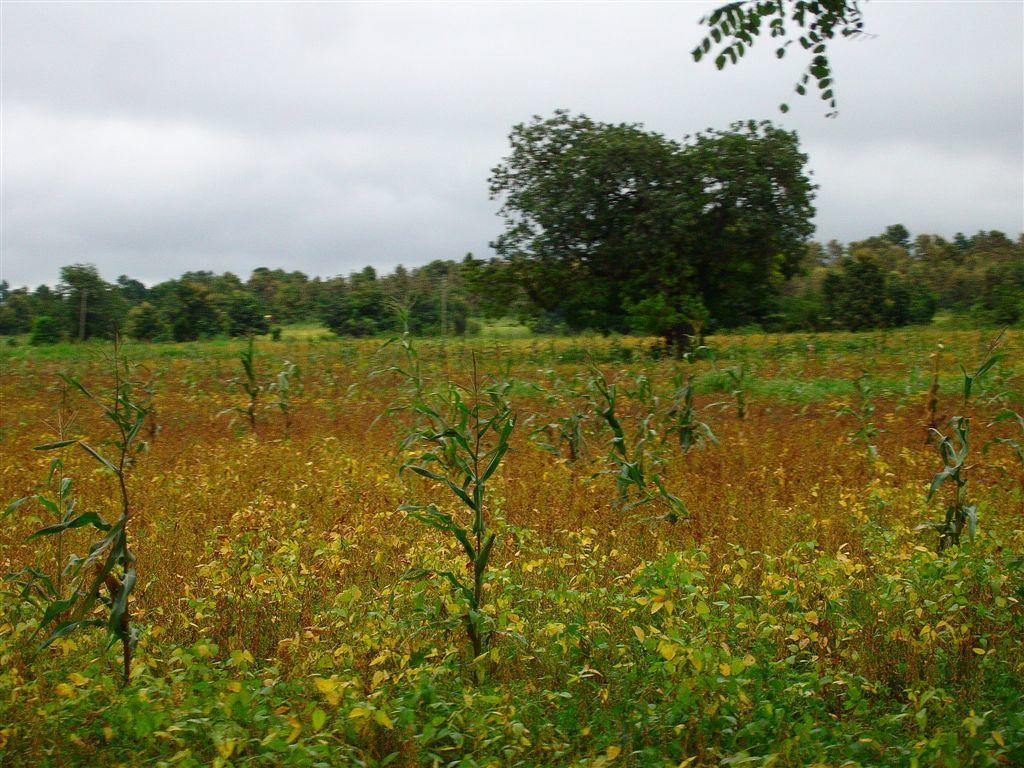Where was the picture taken? The picture was clicked outside. What can be seen in the foreground of the image? There are plants in the foreground of the image. What is located in the center of the image? There are trees and other items visible in the center of the image. What can be seen in the background of the image? The sky is visible in the background of the image. What type of nose can be seen on the tree in the image? There is no nose present on the tree in the image, as trees do not have noses. 